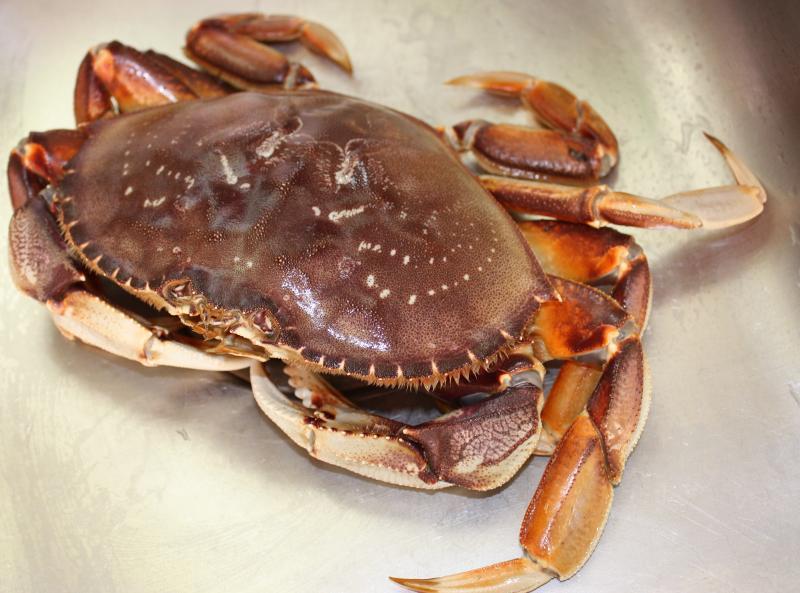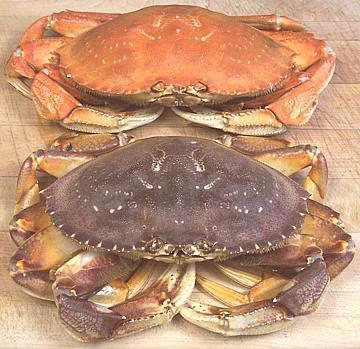The first image is the image on the left, the second image is the image on the right. Given the left and right images, does the statement "All of the crabs in the images are still whole." hold true? Answer yes or no. Yes. The first image is the image on the left, the second image is the image on the right. Evaluate the accuracy of this statement regarding the images: "The left image contains two crabs.". Is it true? Answer yes or no. No. 